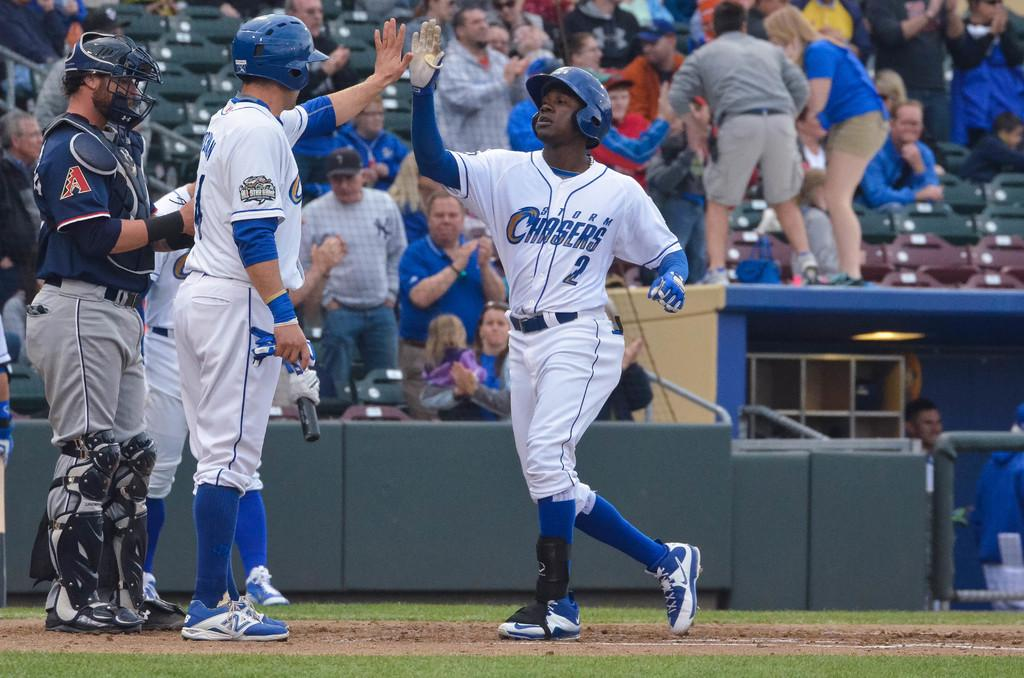<image>
Summarize the visual content of the image. Number 2 for the Storm Chasers just scored a run for his team. 